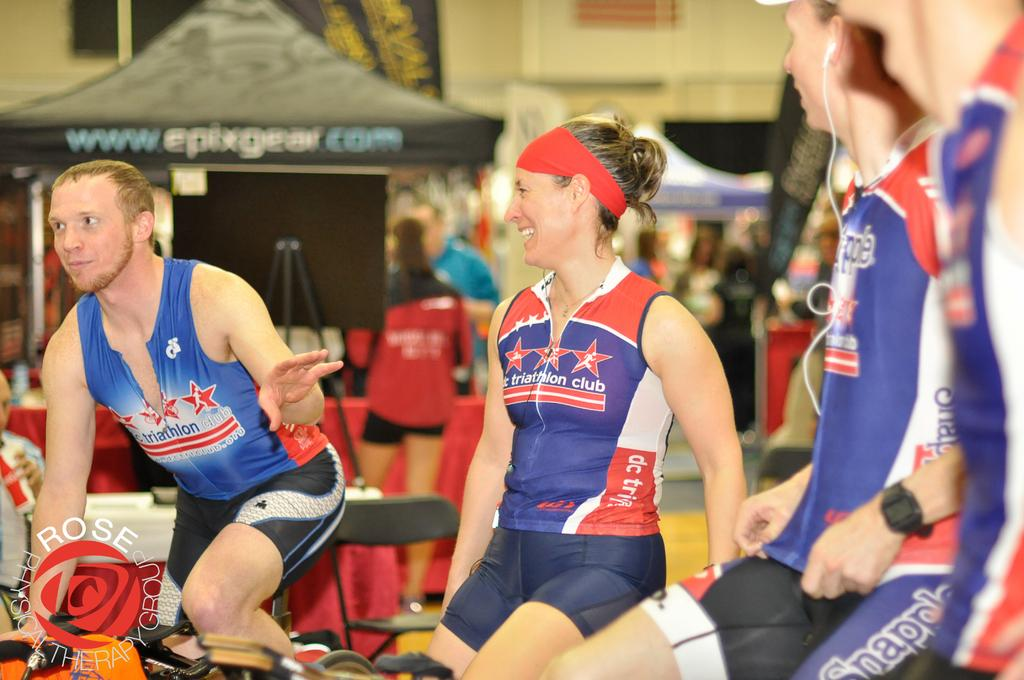<image>
Render a clear and concise summary of the photo. Several people in bike riding gear are sitting close to each other. 